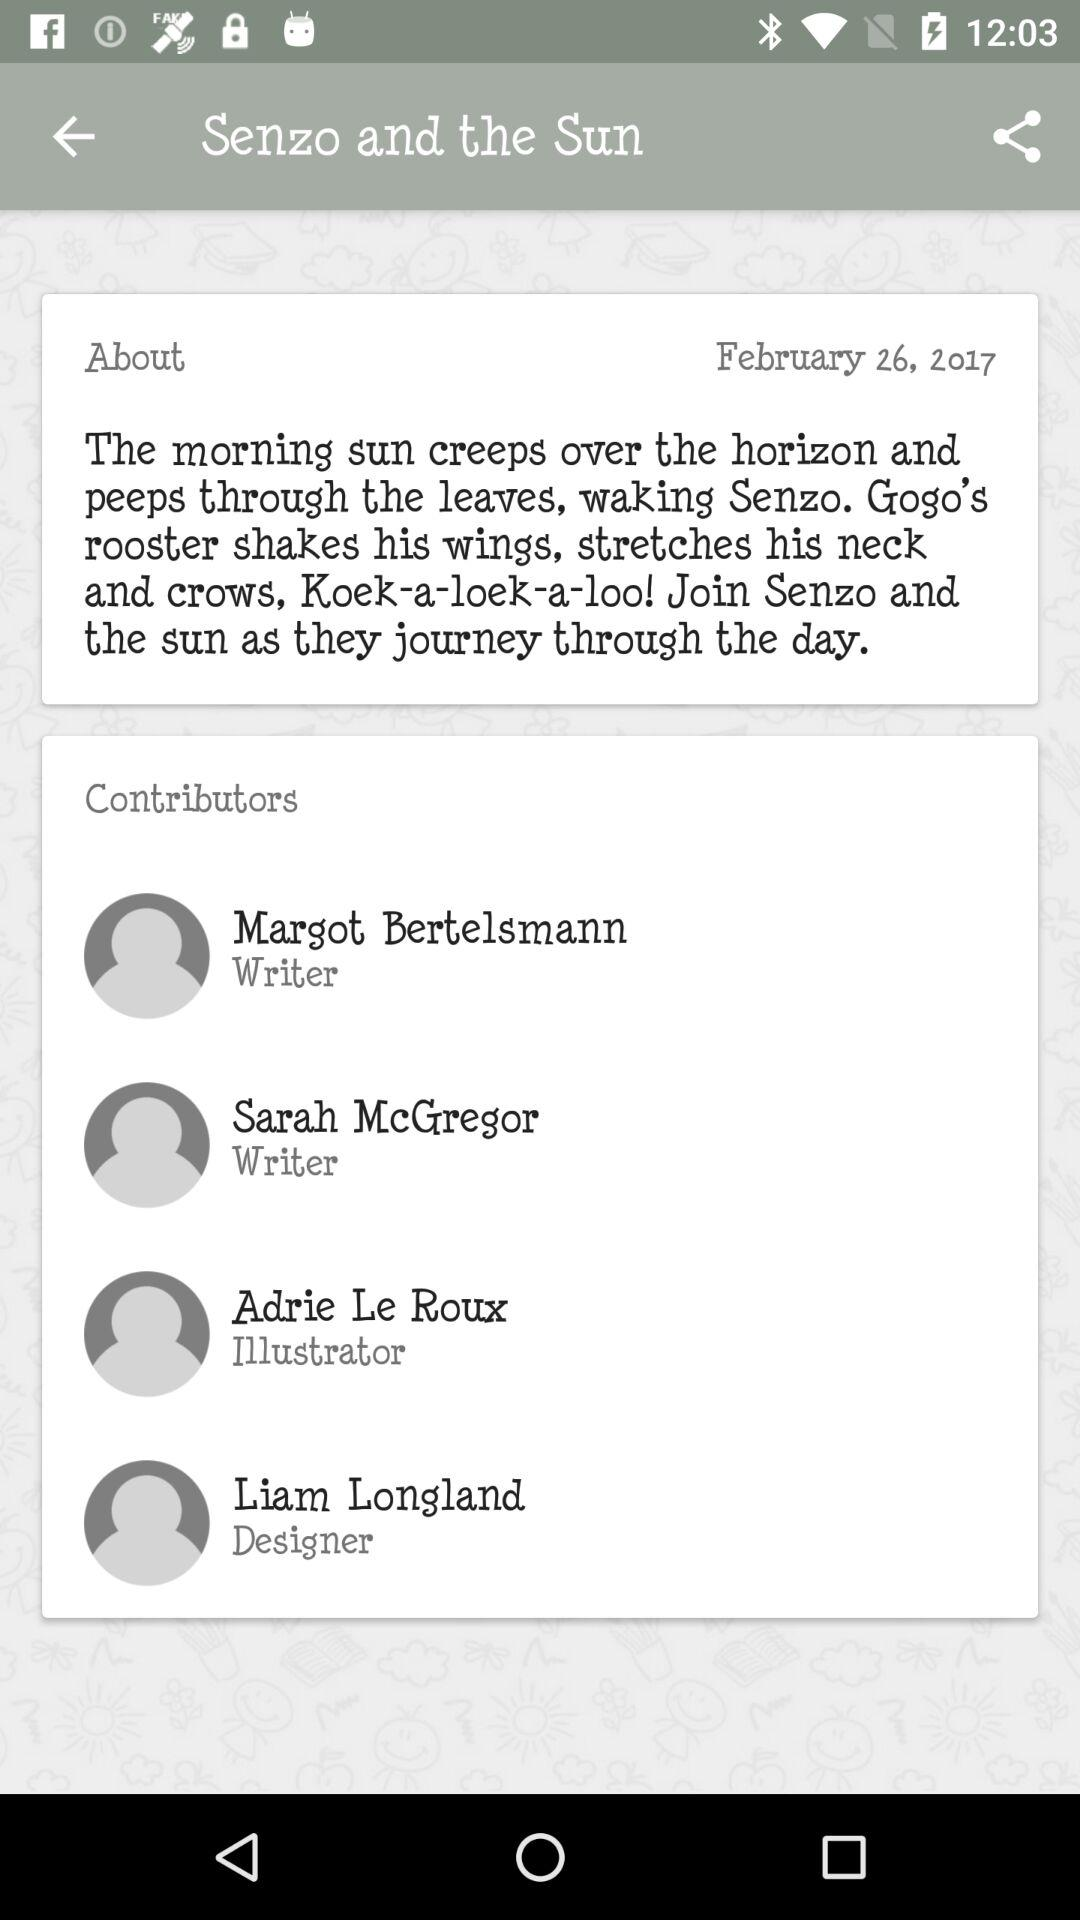Who wrote the book? The book was written by Margot Bertelsmann and Sarah McGregor. 